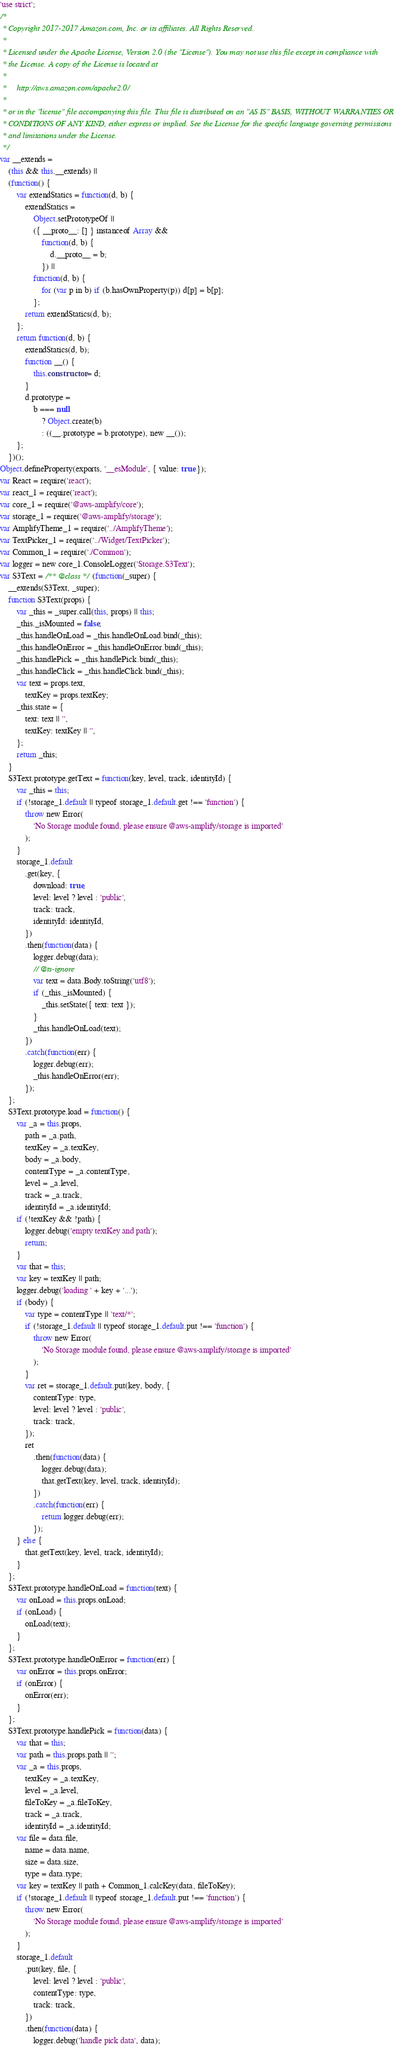<code> <loc_0><loc_0><loc_500><loc_500><_JavaScript_>'use strict';
/*
 * Copyright 2017-2017 Amazon.com, Inc. or its affiliates. All Rights Reserved.
 *
 * Licensed under the Apache License, Version 2.0 (the "License"). You may not use this file except in compliance with
 * the License. A copy of the License is located at
 *
 *     http://aws.amazon.com/apache2.0/
 *
 * or in the "license" file accompanying this file. This file is distributed on an "AS IS" BASIS, WITHOUT WARRANTIES OR
 * CONDITIONS OF ANY KIND, either express or implied. See the License for the specific language governing permissions
 * and limitations under the License.
 */
var __extends =
	(this && this.__extends) ||
	(function() {
		var extendStatics = function(d, b) {
			extendStatics =
				Object.setPrototypeOf ||
				({ __proto__: [] } instanceof Array &&
					function(d, b) {
						d.__proto__ = b;
					}) ||
				function(d, b) {
					for (var p in b) if (b.hasOwnProperty(p)) d[p] = b[p];
				};
			return extendStatics(d, b);
		};
		return function(d, b) {
			extendStatics(d, b);
			function __() {
				this.constructor = d;
			}
			d.prototype =
				b === null
					? Object.create(b)
					: ((__.prototype = b.prototype), new __());
		};
	})();
Object.defineProperty(exports, '__esModule', { value: true });
var React = require('react');
var react_1 = require('react');
var core_1 = require('@aws-amplify/core');
var storage_1 = require('@aws-amplify/storage');
var AmplifyTheme_1 = require('../AmplifyTheme');
var TextPicker_1 = require('../Widget/TextPicker');
var Common_1 = require('./Common');
var logger = new core_1.ConsoleLogger('Storage.S3Text');
var S3Text = /** @class */ (function(_super) {
	__extends(S3Text, _super);
	function S3Text(props) {
		var _this = _super.call(this, props) || this;
		_this._isMounted = false;
		_this.handleOnLoad = _this.handleOnLoad.bind(_this);
		_this.handleOnError = _this.handleOnError.bind(_this);
		_this.handlePick = _this.handlePick.bind(_this);
		_this.handleClick = _this.handleClick.bind(_this);
		var text = props.text,
			textKey = props.textKey;
		_this.state = {
			text: text || '',
			textKey: textKey || '',
		};
		return _this;
	}
	S3Text.prototype.getText = function(key, level, track, identityId) {
		var _this = this;
		if (!storage_1.default || typeof storage_1.default.get !== 'function') {
			throw new Error(
				'No Storage module found, please ensure @aws-amplify/storage is imported'
			);
		}
		storage_1.default
			.get(key, {
				download: true,
				level: level ? level : 'public',
				track: track,
				identityId: identityId,
			})
			.then(function(data) {
				logger.debug(data);
				// @ts-ignore
				var text = data.Body.toString('utf8');
				if (_this._isMounted) {
					_this.setState({ text: text });
				}
				_this.handleOnLoad(text);
			})
			.catch(function(err) {
				logger.debug(err);
				_this.handleOnError(err);
			});
	};
	S3Text.prototype.load = function() {
		var _a = this.props,
			path = _a.path,
			textKey = _a.textKey,
			body = _a.body,
			contentType = _a.contentType,
			level = _a.level,
			track = _a.track,
			identityId = _a.identityId;
		if (!textKey && !path) {
			logger.debug('empty textKey and path');
			return;
		}
		var that = this;
		var key = textKey || path;
		logger.debug('loading ' + key + '...');
		if (body) {
			var type = contentType || 'text/*';
			if (!storage_1.default || typeof storage_1.default.put !== 'function') {
				throw new Error(
					'No Storage module found, please ensure @aws-amplify/storage is imported'
				);
			}
			var ret = storage_1.default.put(key, body, {
				contentType: type,
				level: level ? level : 'public',
				track: track,
			});
			ret
				.then(function(data) {
					logger.debug(data);
					that.getText(key, level, track, identityId);
				})
				.catch(function(err) {
					return logger.debug(err);
				});
		} else {
			that.getText(key, level, track, identityId);
		}
	};
	S3Text.prototype.handleOnLoad = function(text) {
		var onLoad = this.props.onLoad;
		if (onLoad) {
			onLoad(text);
		}
	};
	S3Text.prototype.handleOnError = function(err) {
		var onError = this.props.onError;
		if (onError) {
			onError(err);
		}
	};
	S3Text.prototype.handlePick = function(data) {
		var that = this;
		var path = this.props.path || '';
		var _a = this.props,
			textKey = _a.textKey,
			level = _a.level,
			fileToKey = _a.fileToKey,
			track = _a.track,
			identityId = _a.identityId;
		var file = data.file,
			name = data.name,
			size = data.size,
			type = data.type;
		var key = textKey || path + Common_1.calcKey(data, fileToKey);
		if (!storage_1.default || typeof storage_1.default.put !== 'function') {
			throw new Error(
				'No Storage module found, please ensure @aws-amplify/storage is imported'
			);
		}
		storage_1.default
			.put(key, file, {
				level: level ? level : 'public',
				contentType: type,
				track: track,
			})
			.then(function(data) {
				logger.debug('handle pick data', data);</code> 